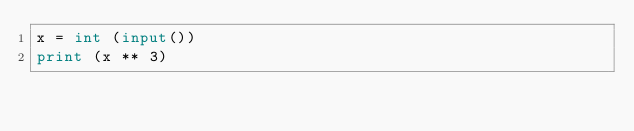Convert code to text. <code><loc_0><loc_0><loc_500><loc_500><_Python_>x = int (input())
print (x ** 3)
</code> 